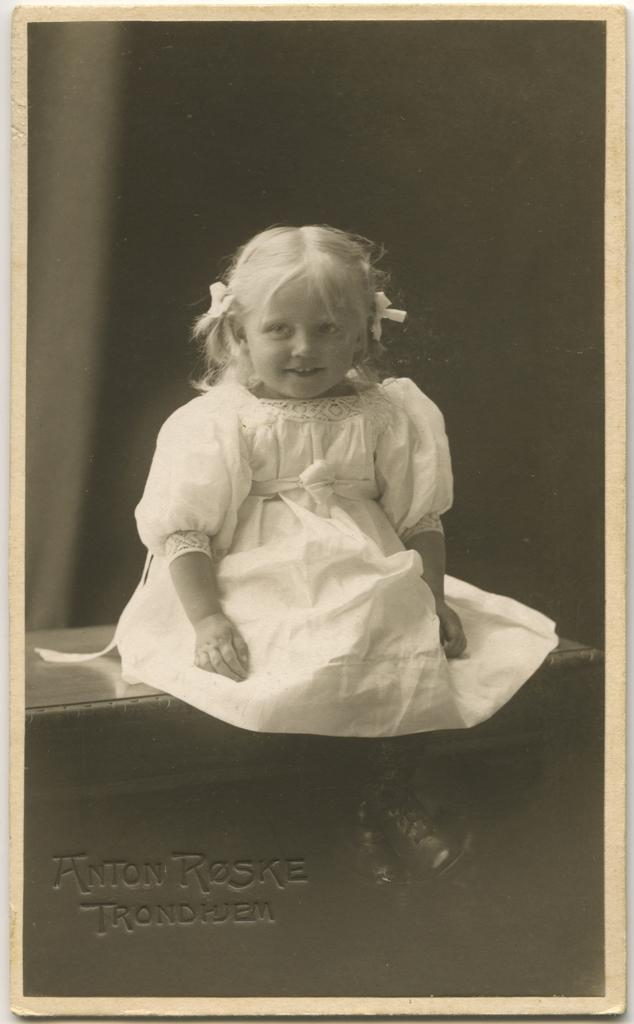What is the color scheme of the image? The image is black and white. What is the main subject of the image? There is a picture of a child in the image. What is the child wearing? The child is wearing a white dress. Where is the child sitting in the image? The child is sitting on a bench. What can be found at the bottom of the image? There is text at the bottom of the image. What type of birds can be seen flying in the image? There are no birds present in the image; it is a black and white picture of a child sitting on a bench. 